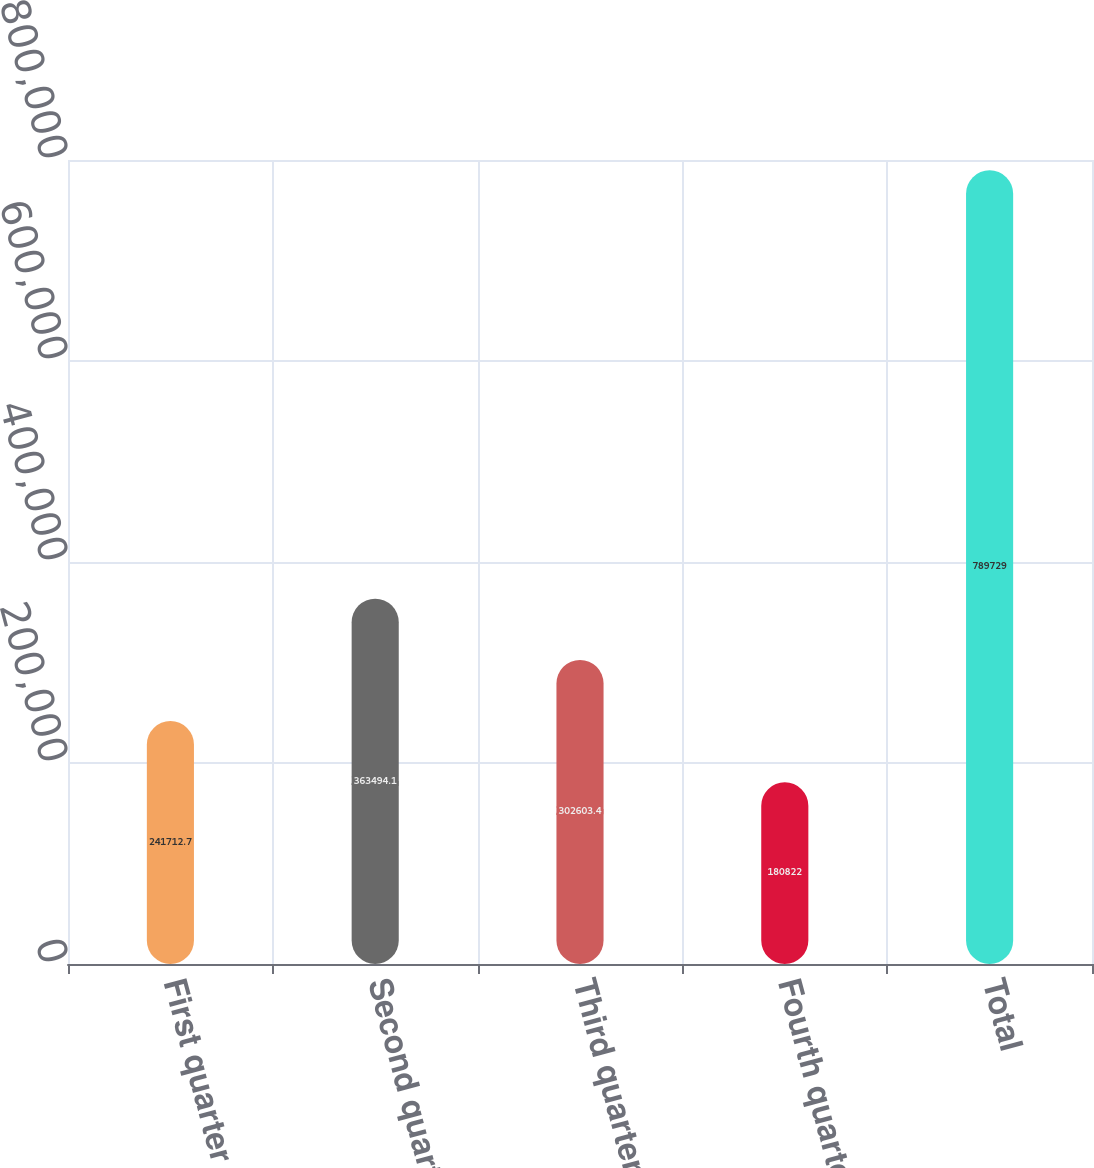Convert chart to OTSL. <chart><loc_0><loc_0><loc_500><loc_500><bar_chart><fcel>First quarter<fcel>Second quarter<fcel>Third quarter<fcel>Fourth quarter<fcel>Total<nl><fcel>241713<fcel>363494<fcel>302603<fcel>180822<fcel>789729<nl></chart> 